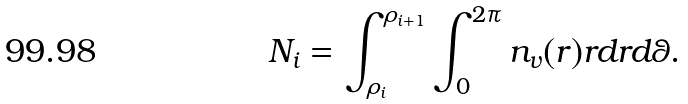Convert formula to latex. <formula><loc_0><loc_0><loc_500><loc_500>N _ { i } = \int _ { \rho _ { i } } ^ { \rho _ { i + 1 } } \int _ { 0 } ^ { 2 \pi } n _ { v } ( { r } ) r d r d \theta .</formula> 